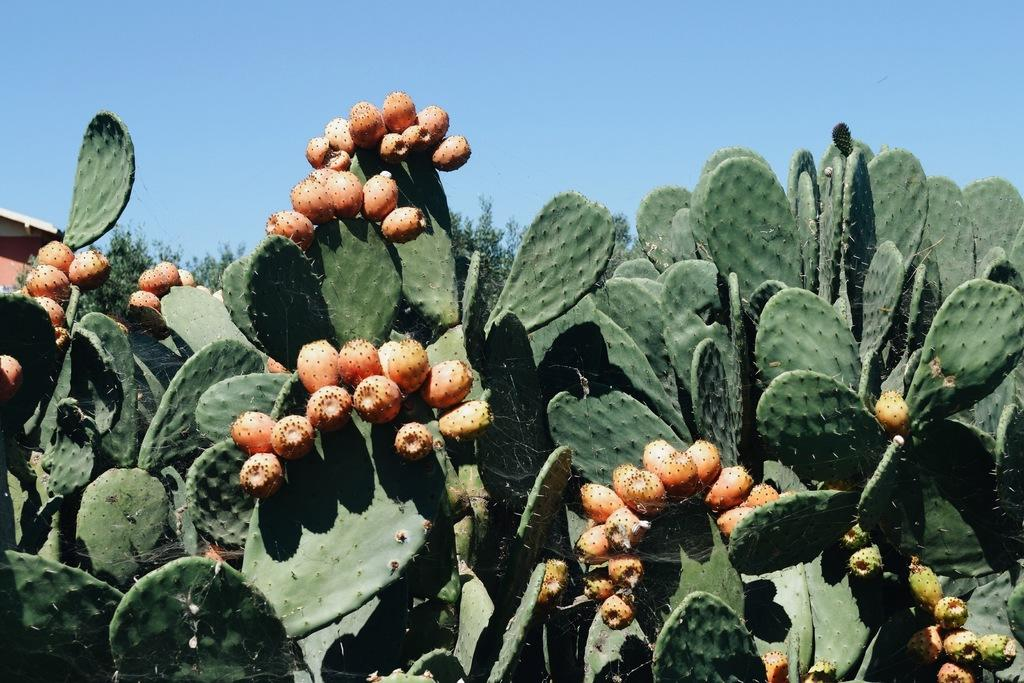What type of plants can be seen in the image? There are plants with fruits in the image. What can be seen in the background of the image? There are trees in the background of the image. What type of structure is visible in the image? There is a structure that looks like a house in the image. What is visible at the top of the image? The sky is visible at the top of the image. Is there a stream visible in the image? There is no stream present in the image. What type of curve can be seen in the structure that looks like a house? There is no curve mentioned in the structure that looks like a house in the image. 